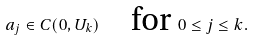Convert formula to latex. <formula><loc_0><loc_0><loc_500><loc_500>a _ { j } \in C ( 0 , U _ { k } ) \quad \text {for } 0 \leq j \leq k .</formula> 